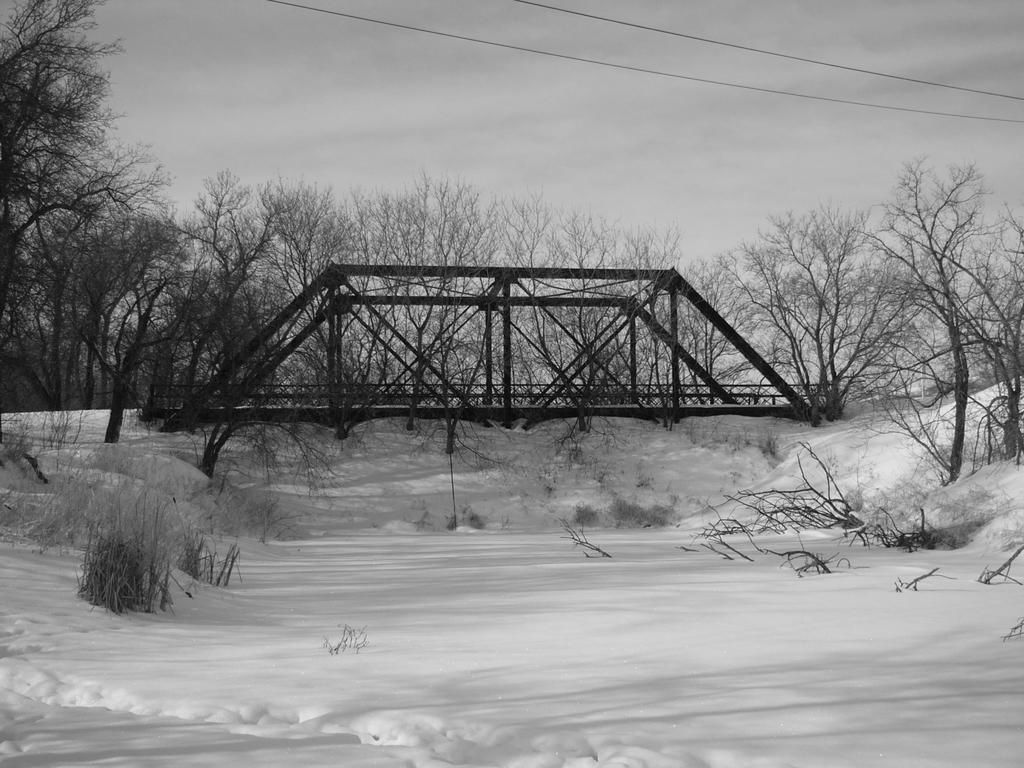What structure is located in the middle of the image? There is a bridge in the middle of the image. What type of vegetation can be seen at the back of the image? There are trees at the back of the image. What is visible at the top of the image? The sky is visible at the top of the image. What else can be seen in the image besides the bridge and trees? There are wires in the image. What is the ground condition at the bottom of the image? Snow is present at the bottom of the image. What type of throat lozenge is visible on the page in the image? There is no throat lozenge or page present in the image. What type of patch is sewn onto the bridge in the image? There is no patch present on the bridge in the image. 